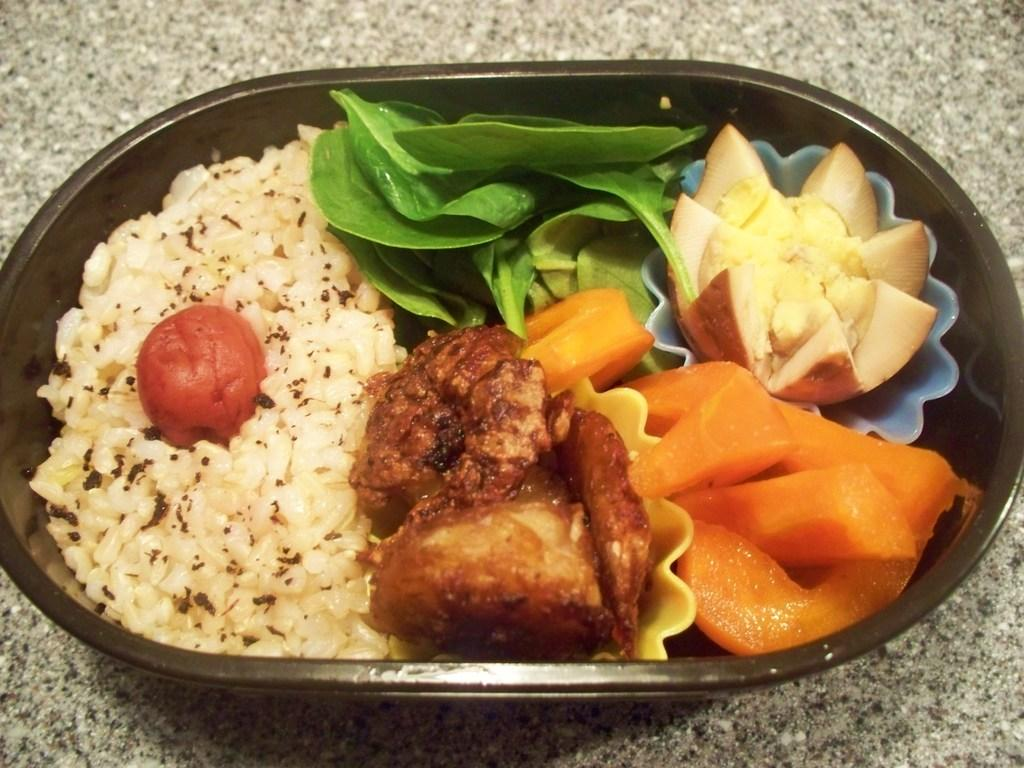What is the main object in the center of the image? There is a table in the center of the image. What is placed on the table? There is a box on the table. What is inside the box? The box contains food items. What color are the toes of the person holding the roof in the image? There is no person holding a roof in the image, and therefore no toes are visible. 